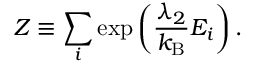Convert formula to latex. <formula><loc_0><loc_0><loc_500><loc_500>Z \equiv \sum _ { i } \exp \left ( { \frac { \lambda _ { 2 } } { k _ { B } } } E _ { i } \right ) .</formula> 